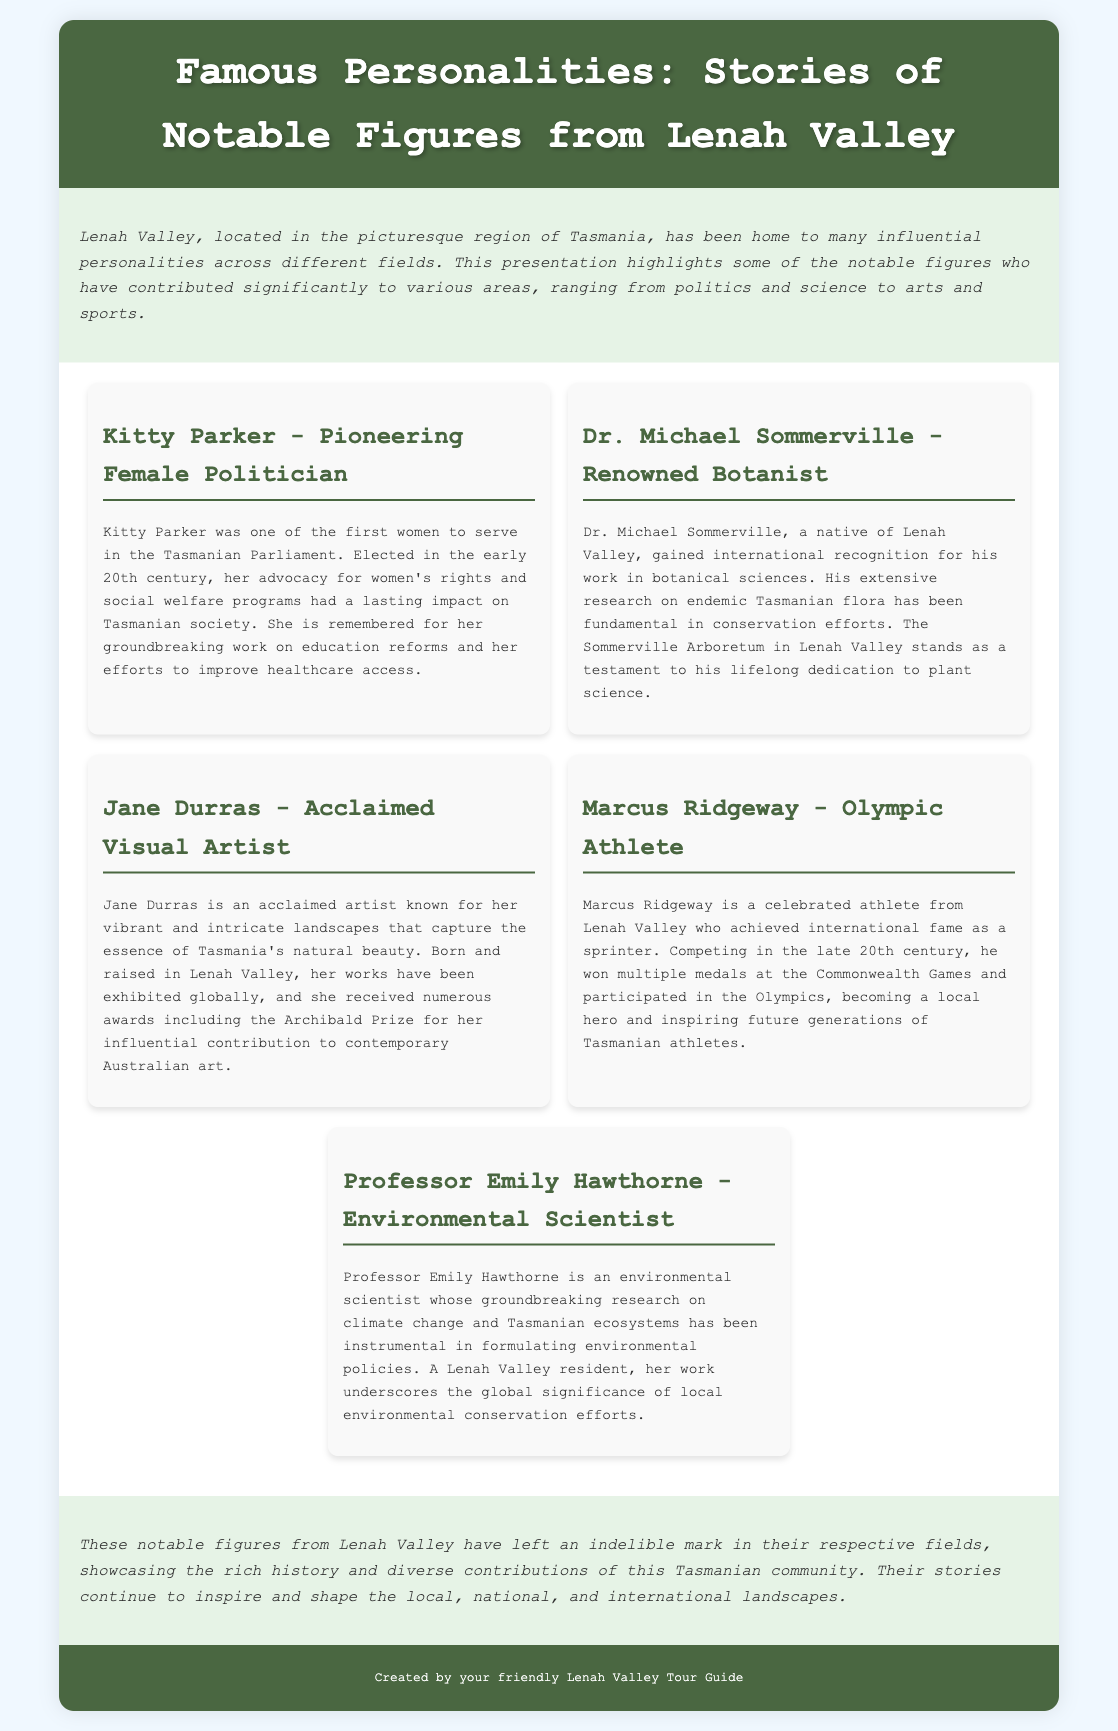What is the title of the presentation? The title is prominently displayed in the header section of the document as "Famous Personalities: Stories of Notable Figures from Lenah Valley."
Answer: Famous Personalities: Stories of Notable Figures from Lenah Valley Who was the first female politician mentioned? The first female politician highlighted in the document is Kitty Parker, noted for her political contributions.
Answer: Kitty Parker What field is Dr. Michael Sommerville associated with? The document states that Dr. Michael Sommerville is a renowned botanist recognized for his work in botanical sciences.
Answer: Botany Which award did Jane Durras receive? The text mentions that Jane Durras received the Archibald Prize for her contributions to Australian art.
Answer: Archibald Prize How many medals did Marcus Ridgeway win at the Commonwealth Games? The document indicates that Marcus Ridgeway won multiple medals, but it does not specify a number.
Answer: Multiple medals What is one significant contribution of Professor Emily Hawthorne? The document highlights that Professor Emily Hawthorne's research has been instrumental in formulating environmental policies regarding climate change.
Answer: Environmental policies What type of artistic work is Jane Durras known for? According to the document, Jane Durras is known for her vibrant and intricate landscapes that illustrate Tasmania's natural beauty.
Answer: Landscapes What is the focus of the introductory section? The introduction provides a brief overview of the influential personalities from Lenah Valley and their contributions across various fields.
Answer: Overview of influential personalities What is the significance of the Sommerville Arboretum? The Sommerville Arboretum in Lenah Valley is a testament to Dr. Michael Sommerville's lifelong dedication to plant science as described in the document.
Answer: Testament to plant science 